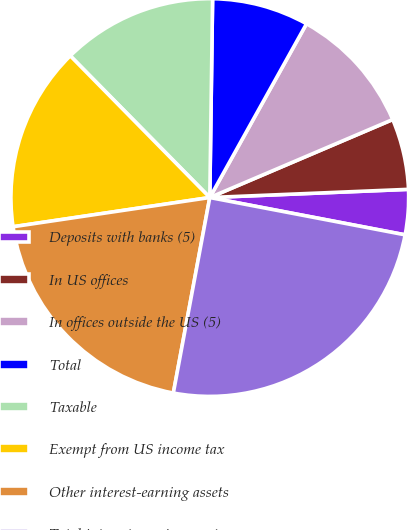Convert chart. <chart><loc_0><loc_0><loc_500><loc_500><pie_chart><fcel>Deposits with banks (5)<fcel>In US offices<fcel>In offices outside the US (5)<fcel>Total<fcel>Taxable<fcel>Exempt from US income tax<fcel>Other interest-earning assets<fcel>Total interest-earning assets<nl><fcel>3.66%<fcel>5.76%<fcel>10.5%<fcel>7.86%<fcel>12.6%<fcel>14.97%<fcel>19.72%<fcel>24.93%<nl></chart> 